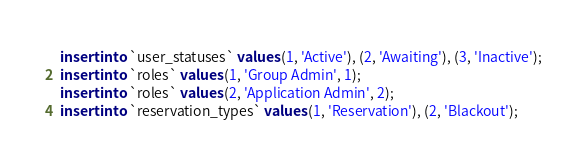<code> <loc_0><loc_0><loc_500><loc_500><_SQL_>insert into `user_statuses` values (1, 'Active'), (2, 'Awaiting'), (3, 'Inactive');
insert into `roles` values (1, 'Group Admin', 1);
insert into `roles` values (2, 'Application Admin', 2);
insert into `reservation_types` values (1, 'Reservation'), (2, 'Blackout');</code> 